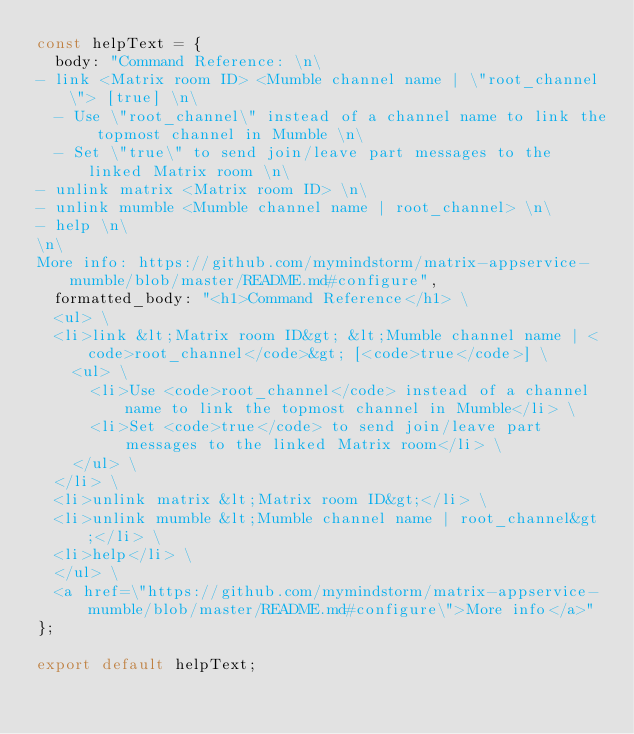<code> <loc_0><loc_0><loc_500><loc_500><_TypeScript_>const helpText = {
  body: "Command Reference: \n\
- link <Matrix room ID> <Mumble channel name | \"root_channel\"> [true] \n\
  - Use \"root_channel\" instead of a channel name to link the topmost channel in Mumble \n\
  - Set \"true\" to send join/leave part messages to the linked Matrix room \n\
- unlink matrix <Matrix room ID> \n\
- unlink mumble <Mumble channel name | root_channel> \n\
- help \n\
\n\
More info: https://github.com/mymindstorm/matrix-appservice-mumble/blob/master/README.md#configure",
  formatted_body: "<h1>Command Reference</h1> \
  <ul> \
  <li>link &lt;Matrix room ID&gt; &lt;Mumble channel name | <code>root_channel</code>&gt; [<code>true</code>] \
    <ul> \
      <li>Use <code>root_channel</code> instead of a channel name to link the topmost channel in Mumble</li> \
      <li>Set <code>true</code> to send join/leave part messages to the linked Matrix room</li> \
    </ul> \
  </li> \
  <li>unlink matrix &lt;Matrix room ID&gt;</li> \
  <li>unlink mumble &lt;Mumble channel name | root_channel&gt;</li> \
  <li>help</li> \
  </ul> \
  <a href=\"https://github.com/mymindstorm/matrix-appservice-mumble/blob/master/README.md#configure\">More info</a>"
};

export default helpText;
</code> 